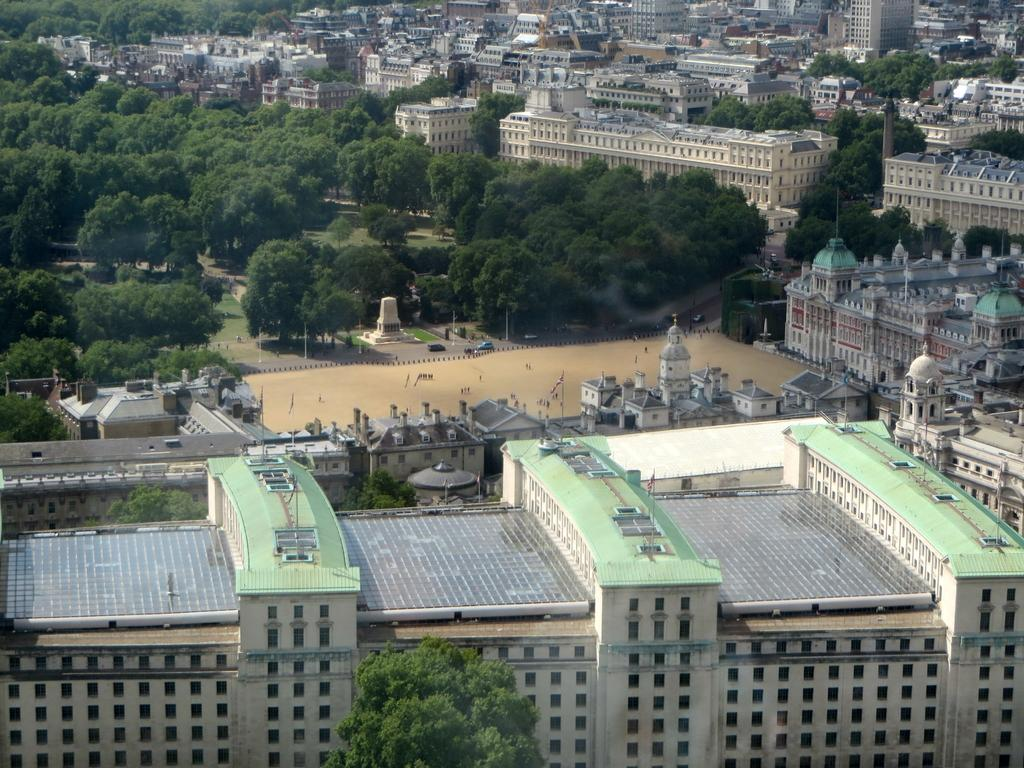What type of structures can be seen in the image? There are buildings in the image. What other natural elements are present in the image? There are trees in the image. Are there any specific features on top of the buildings? Yes, there are flag poles on top of the buildings. What can be seen moving on the road in the image? There are vehicles on the road in the image. Who is the owner of the island in the image? There is no island present in the image, so it is not possible to determine the owner. Can you describe the type of shake that is being offered at the building in the image? There is no mention of a shake or any food or drink being offered in the image. 